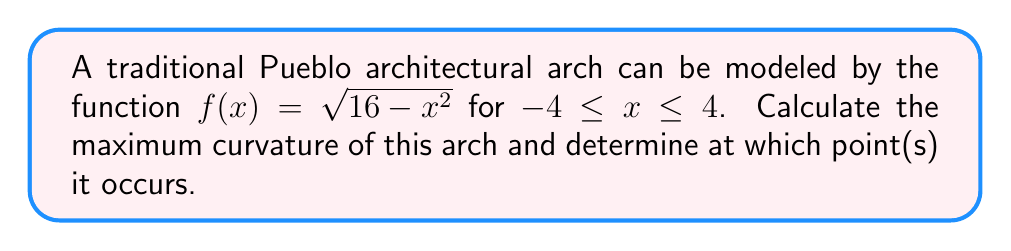Solve this math problem. To find the maximum curvature and its location, we'll follow these steps:

1) The curvature formula is given by:
   $$\kappa = \frac{|f''(x)|}{(1+[f'(x)]^2)^{3/2}}$$

2) First, let's find $f'(x)$ and $f''(x)$:
   $$f'(x) = \frac{-x}{\sqrt{16-x^2}}$$
   $$f''(x) = \frac{-16}{(16-x^2)^{3/2}}$$

3) Now, let's substitute these into the curvature formula:
   $$\kappa = \frac{|\frac{-16}{(16-x^2)^{3/2}}|}{(1+[\frac{-x}{\sqrt{16-x^2}}]^2)^{3/2}}$$

4) Simplify:
   $$\kappa = \frac{16}{(16-x^2)^{3/2}} \cdot \frac{1}{(1+\frac{x^2}{16-x^2})^{3/2}}$$
   $$\kappa = \frac{16}{(16-x^2+x^2)^{3/2}} = \frac{16}{16^{3/2}} = \frac{1}{4}$$

5) We see that the curvature is constant, $\kappa = \frac{1}{4}$, for all points on the arch.

6) This constant curvature is also the maximum curvature, and it occurs at all points on the arch.

7) However, in architectural terms, the point of maximum structural stress is typically at the center of the arch, which is at $x=0$.
Answer: Maximum curvature: $\frac{1}{4}$; occurs at all points, notably at $x=0$. 